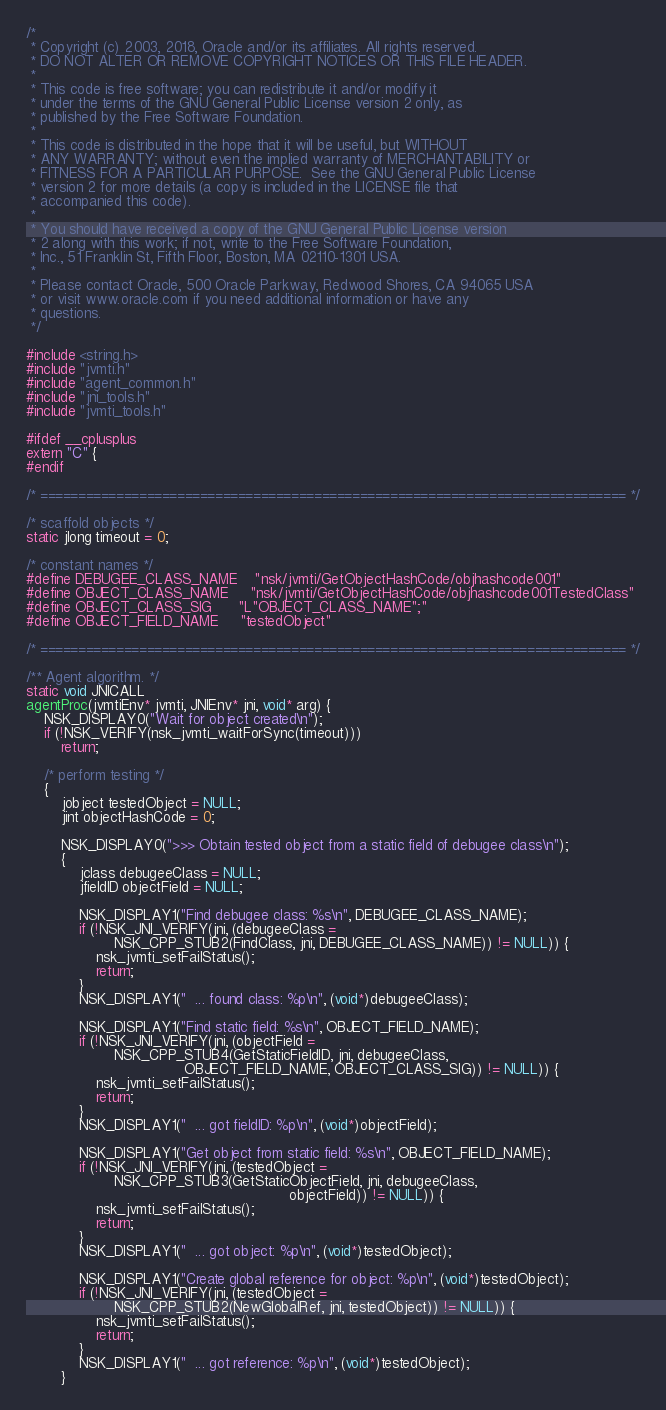Convert code to text. <code><loc_0><loc_0><loc_500><loc_500><_C_>/*
 * Copyright (c) 2003, 2018, Oracle and/or its affiliates. All rights reserved.
 * DO NOT ALTER OR REMOVE COPYRIGHT NOTICES OR THIS FILE HEADER.
 *
 * This code is free software; you can redistribute it and/or modify it
 * under the terms of the GNU General Public License version 2 only, as
 * published by the Free Software Foundation.
 *
 * This code is distributed in the hope that it will be useful, but WITHOUT
 * ANY WARRANTY; without even the implied warranty of MERCHANTABILITY or
 * FITNESS FOR A PARTICULAR PURPOSE.  See the GNU General Public License
 * version 2 for more details (a copy is included in the LICENSE file that
 * accompanied this code).
 *
 * You should have received a copy of the GNU General Public License version
 * 2 along with this work; if not, write to the Free Software Foundation,
 * Inc., 51 Franklin St, Fifth Floor, Boston, MA 02110-1301 USA.
 *
 * Please contact Oracle, 500 Oracle Parkway, Redwood Shores, CA 94065 USA
 * or visit www.oracle.com if you need additional information or have any
 * questions.
 */

#include <string.h>
#include "jvmti.h"
#include "agent_common.h"
#include "jni_tools.h"
#include "jvmti_tools.h"

#ifdef __cplusplus
extern "C" {
#endif

/* ============================================================================= */

/* scaffold objects */
static jlong timeout = 0;

/* constant names */
#define DEBUGEE_CLASS_NAME    "nsk/jvmti/GetObjectHashCode/objhashcode001"
#define OBJECT_CLASS_NAME     "nsk/jvmti/GetObjectHashCode/objhashcode001TestedClass"
#define OBJECT_CLASS_SIG      "L"OBJECT_CLASS_NAME";"
#define OBJECT_FIELD_NAME     "testedObject"

/* ============================================================================= */

/** Agent algorithm. */
static void JNICALL
agentProc(jvmtiEnv* jvmti, JNIEnv* jni, void* arg) {
    NSK_DISPLAY0("Wait for object created\n");
    if (!NSK_VERIFY(nsk_jvmti_waitForSync(timeout)))
        return;

    /* perform testing */
    {
        jobject testedObject = NULL;
        jint objectHashCode = 0;

        NSK_DISPLAY0(">>> Obtain tested object from a static field of debugee class\n");
        {
            jclass debugeeClass = NULL;
            jfieldID objectField = NULL;

            NSK_DISPLAY1("Find debugee class: %s\n", DEBUGEE_CLASS_NAME);
            if (!NSK_JNI_VERIFY(jni, (debugeeClass =
                    NSK_CPP_STUB2(FindClass, jni, DEBUGEE_CLASS_NAME)) != NULL)) {
                nsk_jvmti_setFailStatus();
                return;
            }
            NSK_DISPLAY1("  ... found class: %p\n", (void*)debugeeClass);

            NSK_DISPLAY1("Find static field: %s\n", OBJECT_FIELD_NAME);
            if (!NSK_JNI_VERIFY(jni, (objectField =
                    NSK_CPP_STUB4(GetStaticFieldID, jni, debugeeClass,
                                    OBJECT_FIELD_NAME, OBJECT_CLASS_SIG)) != NULL)) {
                nsk_jvmti_setFailStatus();
                return;
            }
            NSK_DISPLAY1("  ... got fieldID: %p\n", (void*)objectField);

            NSK_DISPLAY1("Get object from static field: %s\n", OBJECT_FIELD_NAME);
            if (!NSK_JNI_VERIFY(jni, (testedObject =
                    NSK_CPP_STUB3(GetStaticObjectField, jni, debugeeClass,
                                                            objectField)) != NULL)) {
                nsk_jvmti_setFailStatus();
                return;
            }
            NSK_DISPLAY1("  ... got object: %p\n", (void*)testedObject);

            NSK_DISPLAY1("Create global reference for object: %p\n", (void*)testedObject);
            if (!NSK_JNI_VERIFY(jni, (testedObject =
                    NSK_CPP_STUB2(NewGlobalRef, jni, testedObject)) != NULL)) {
                nsk_jvmti_setFailStatus();
                return;
            }
            NSK_DISPLAY1("  ... got reference: %p\n", (void*)testedObject);
        }
</code> 